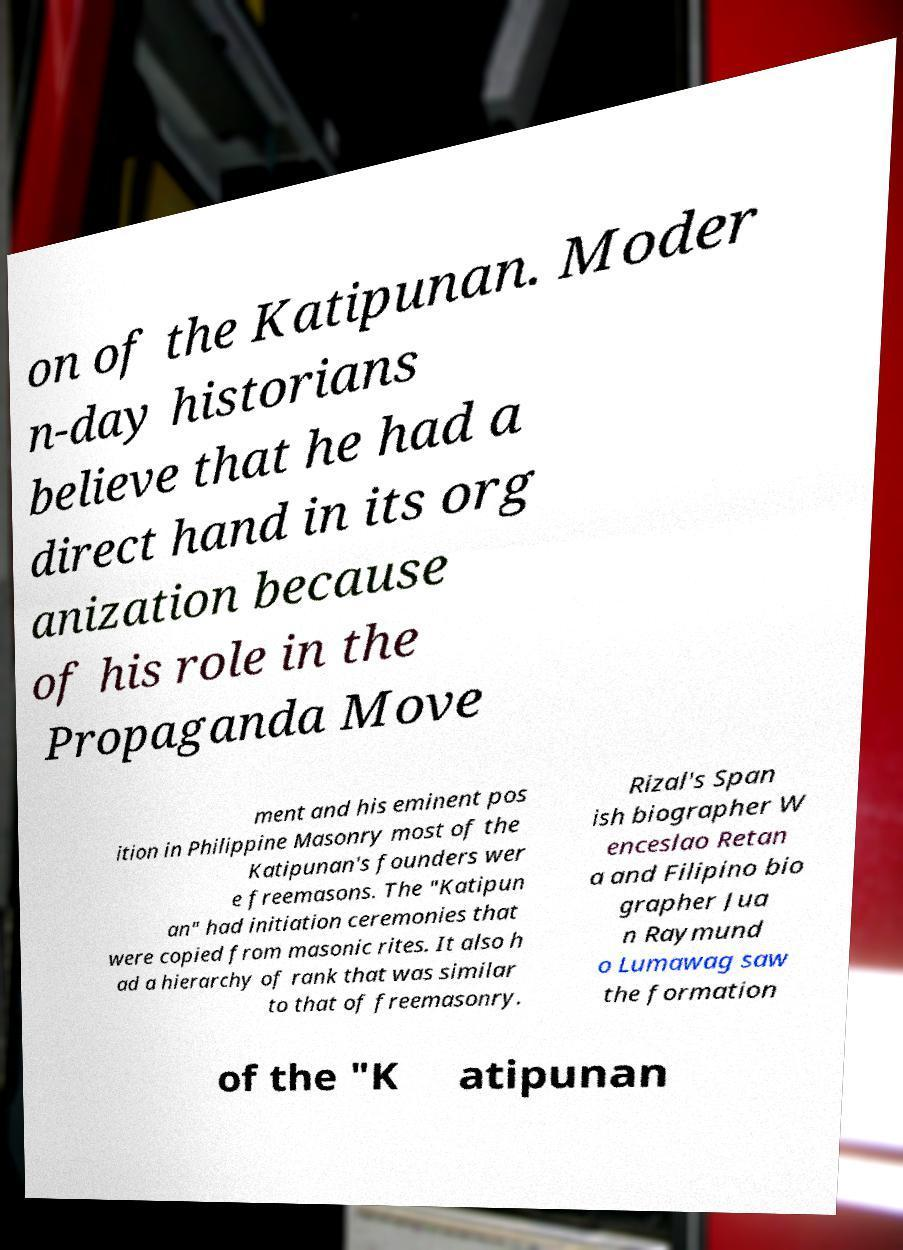Could you extract and type out the text from this image? on of the Katipunan. Moder n-day historians believe that he had a direct hand in its org anization because of his role in the Propaganda Move ment and his eminent pos ition in Philippine Masonry most of the Katipunan's founders wer e freemasons. The "Katipun an" had initiation ceremonies that were copied from masonic rites. It also h ad a hierarchy of rank that was similar to that of freemasonry. Rizal's Span ish biographer W enceslao Retan a and Filipino bio grapher Jua n Raymund o Lumawag saw the formation of the "K atipunan 